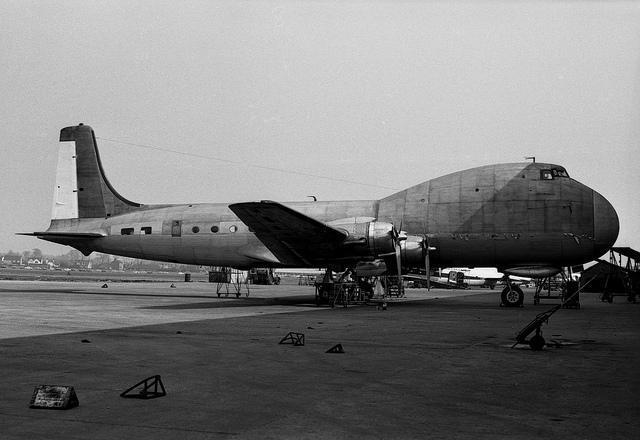How many airplanes do you see?
Give a very brief answer. 1. 